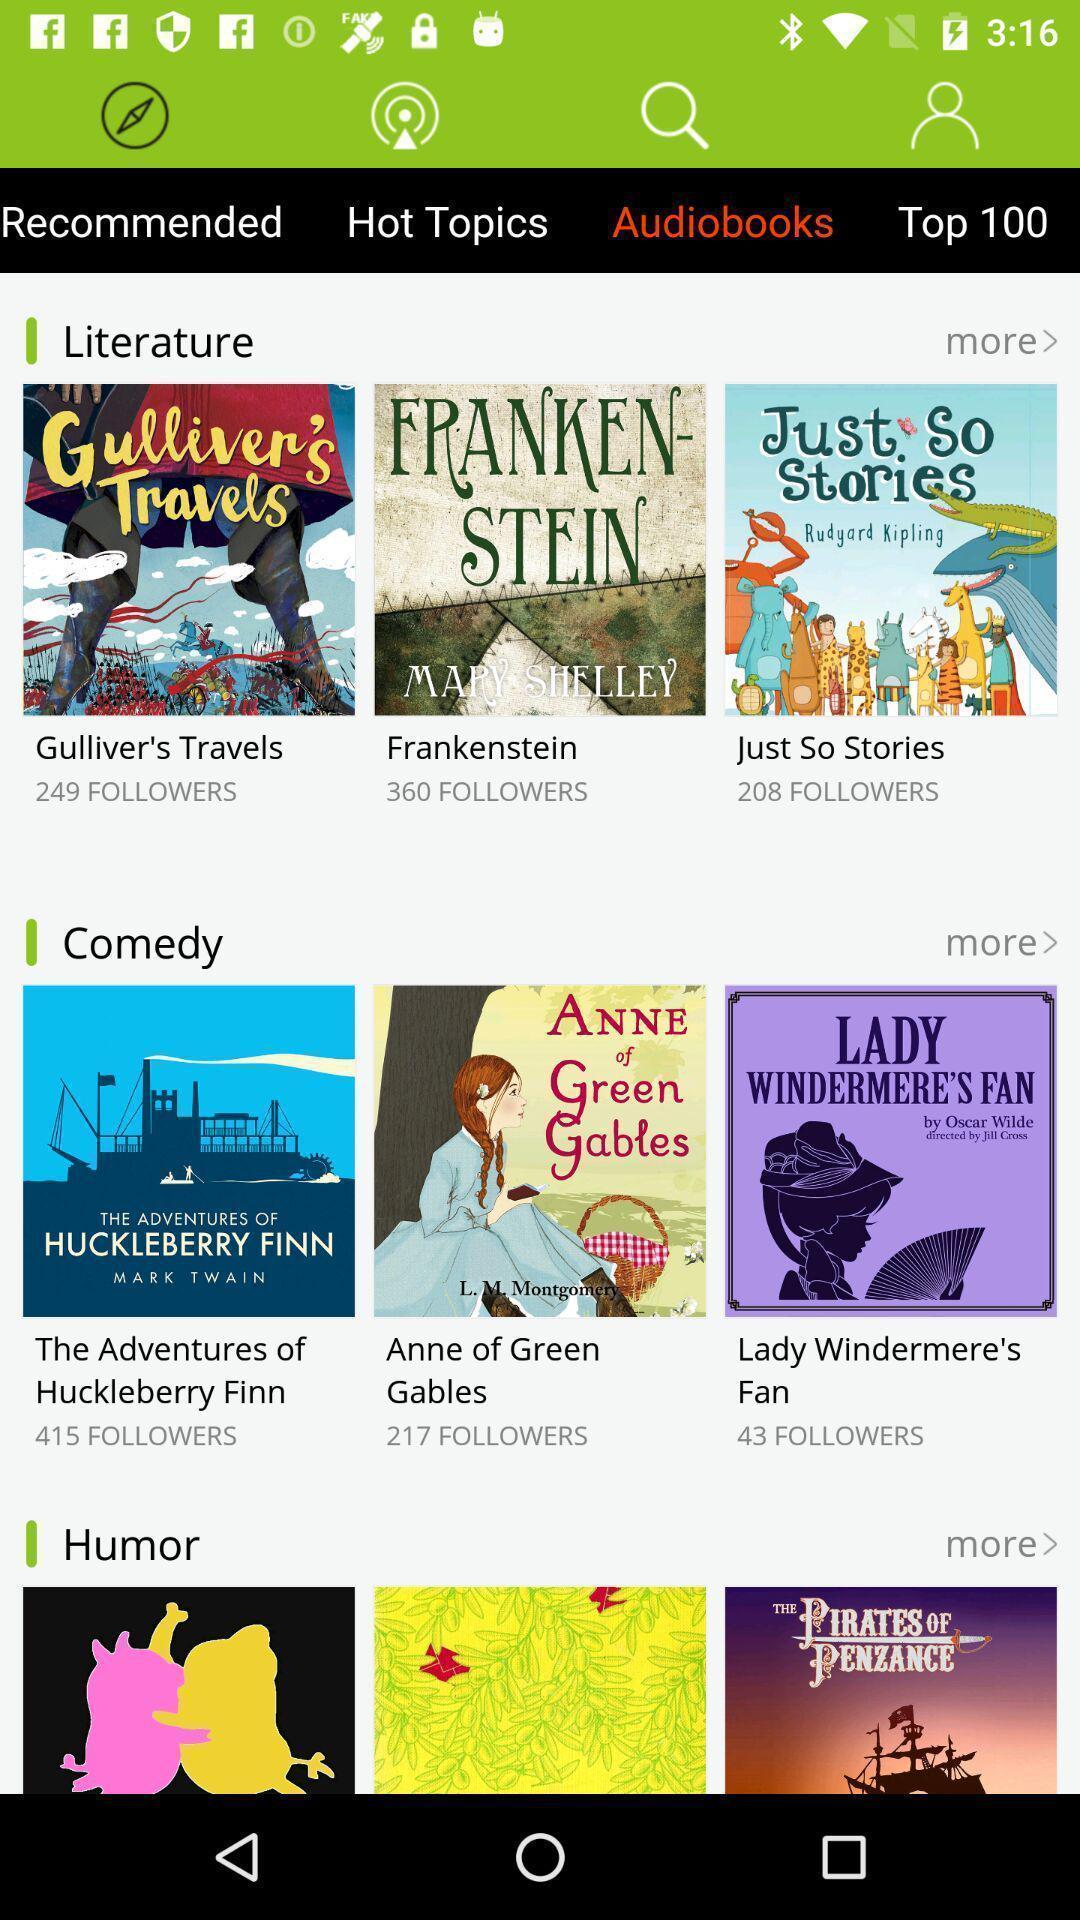Describe the visual elements of this screenshot. Page shows the various audiobooks on music app. 